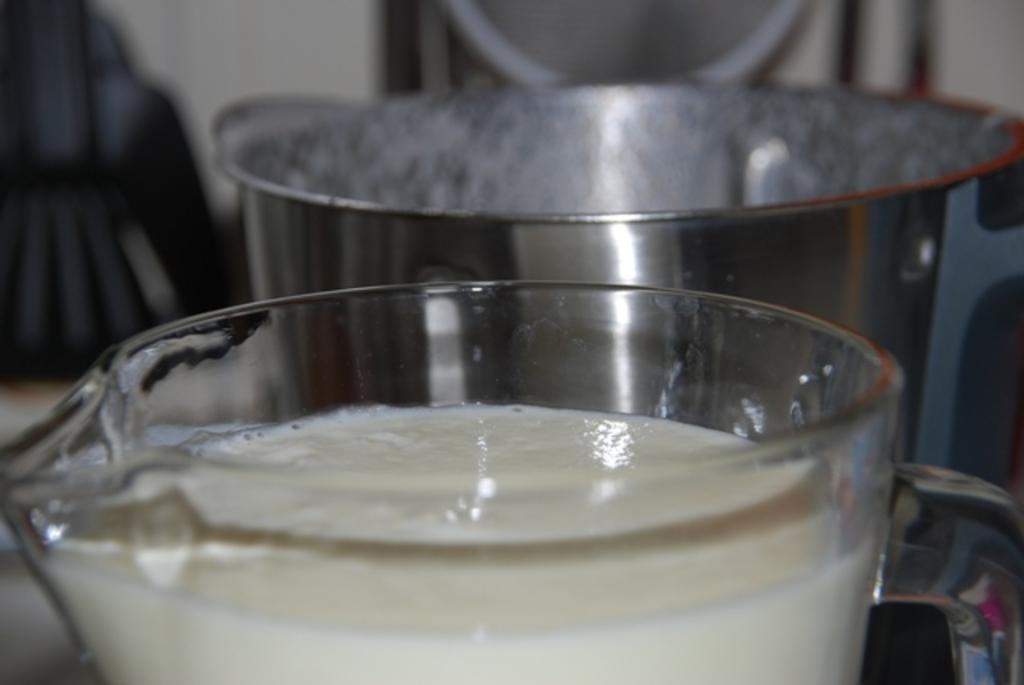Could you give a brief overview of what you see in this image? In this image in the foreground there is a glass jar and in the jar there is a liquid, and beside the glass jar there is a steel vessel and there is a blurry background. 